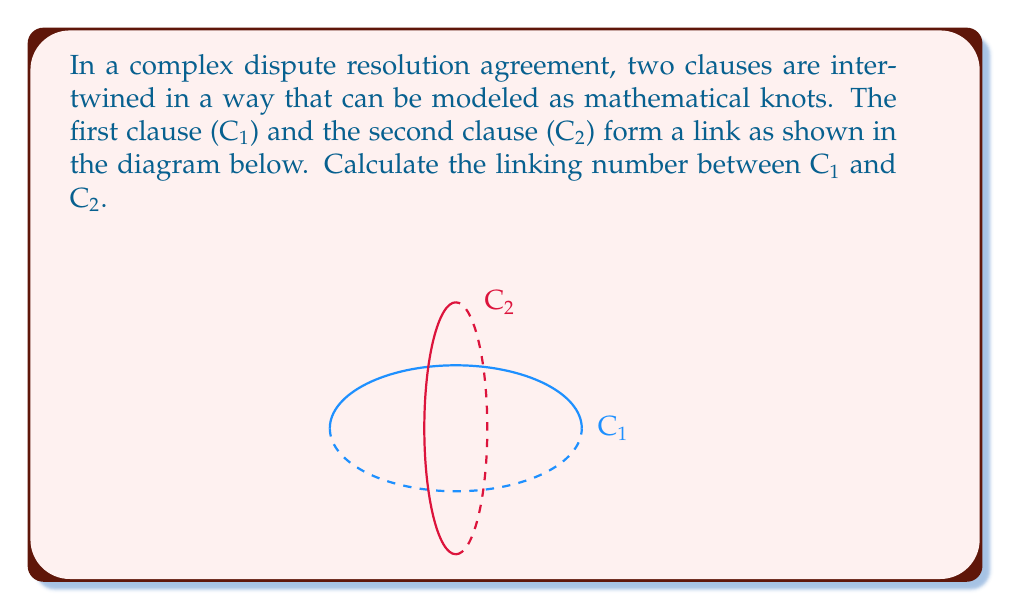Provide a solution to this math problem. To calculate the linking number between two clauses C1 and C2, we'll follow these steps:

1) The linking number is defined as half the sum of the signed crossings in a regular projection of the link.

2) In this diagram, we have a regular projection where C1 (blue) and C2 (red) intersect at four points.

3) We need to determine the sign of each crossing. To do this:
   - Choose an orientation for each clause (e.g., clockwise when viewed from above).
   - At each crossing, if the overcrossing strand can be rotated counterclockwise to align with the undercrossing strand (following their orientations), the crossing is positive (+1). Otherwise, it's negative (-1).

4) Examining the crossings:
   - Top crossing: C2 over C1, positive (+1)
   - Right crossing: C1 over C2, negative (-1)
   - Bottom crossing: C2 over C1, positive (+1)
   - Left crossing: C1 over C2, negative (-1)

5) Sum of signed crossings: (+1) + (-1) + (+1) + (-1) = 0

6) The linking number is half of this sum:

   $$ \text{Linking Number} = \frac{1}{2} \sum \text{(signed crossings)} = \frac{1}{2} \cdot 0 = 0 $$

Therefore, the linking number between clauses C1 and C2 is 0.
Answer: 0 